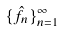Convert formula to latex. <formula><loc_0><loc_0><loc_500><loc_500>\{ \hat { f } _ { n } \} _ { n = 1 } ^ { \infty }</formula> 